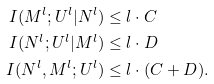<formula> <loc_0><loc_0><loc_500><loc_500>I ( M ^ { l } ; U ^ { l } | N ^ { l } ) & \leq l \cdot C \\ I ( N ^ { l } ; U ^ { l } | M ^ { l } ) & \leq l \cdot D \\ I ( N ^ { l } , M ^ { l } ; U ^ { l } ) & \leq l \cdot ( C + D ) .</formula> 